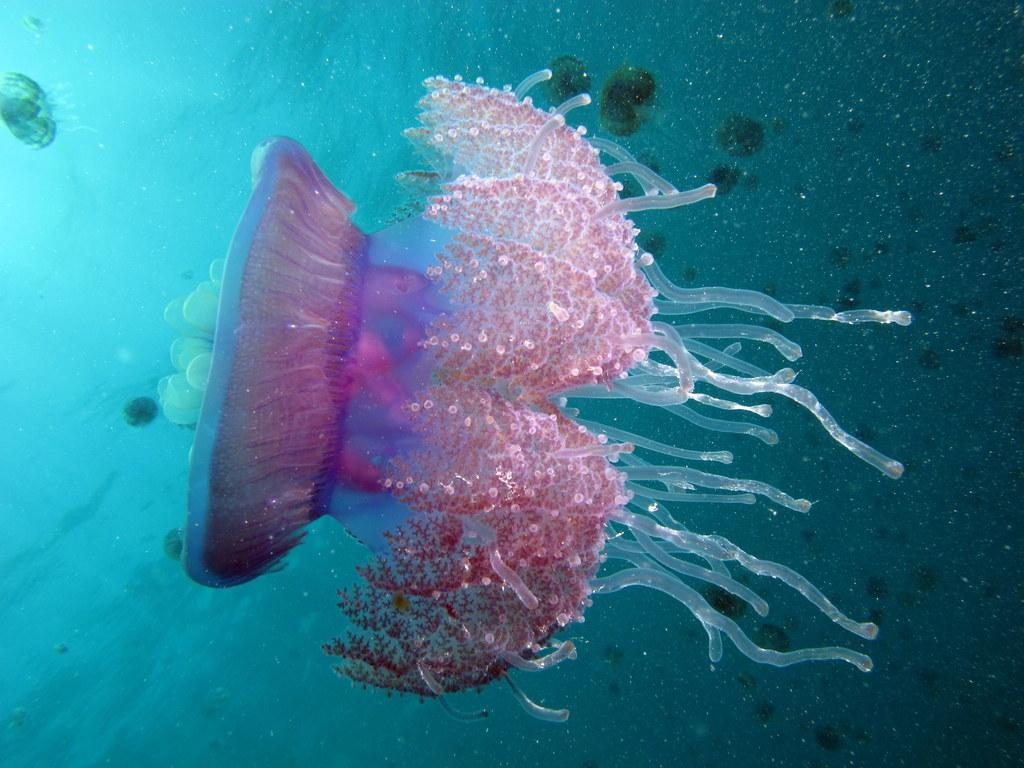What type of marine animals are in the image? There are jellyfishes in the image. Where are the jellyfishes located? The jellyfishes are in the water. What type of face can be seen on the jellyfishes in the image? Jellyfishes do not have faces, as they are invertebrates without a centralized nervous system or a brain. Are there any rats present in the image? There are no rats present in the image; it features jellyfishes in the water. 